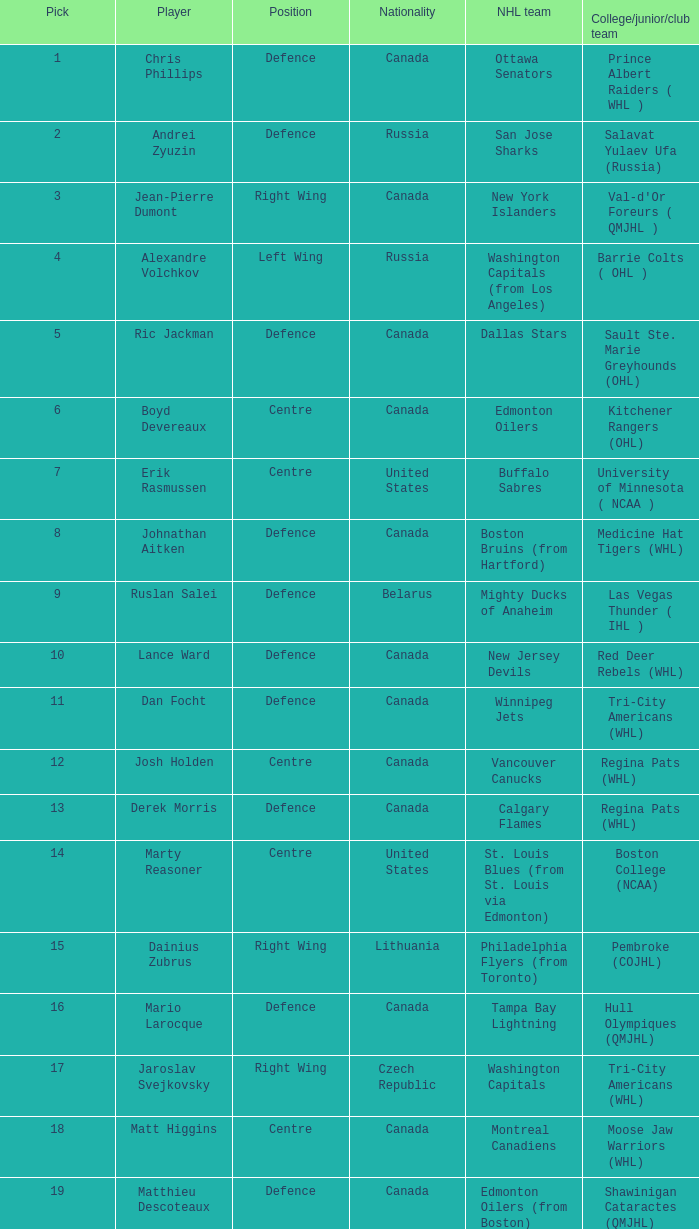How many positions does the draft pick whose nationality is Czech Republic play? 1.0. 